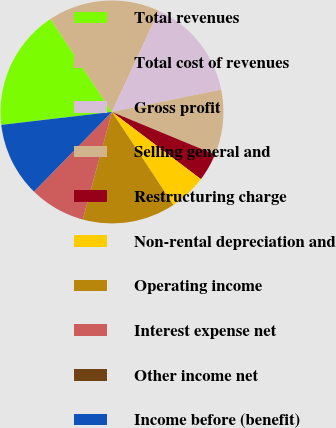Convert chart. <chart><loc_0><loc_0><loc_500><loc_500><pie_chart><fcel>Total revenues<fcel>Total cost of revenues<fcel>Gross profit<fcel>Selling general and<fcel>Restructuring charge<fcel>Non-rental depreciation and<fcel>Operating income<fcel>Interest expense net<fcel>Other income net<fcel>Income before (benefit)<nl><fcel>17.56%<fcel>16.21%<fcel>14.86%<fcel>9.46%<fcel>4.06%<fcel>5.41%<fcel>13.51%<fcel>8.11%<fcel>0.01%<fcel>10.81%<nl></chart> 